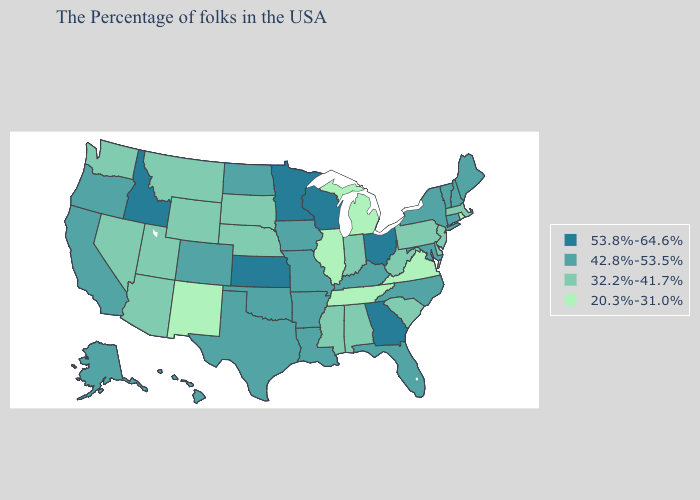How many symbols are there in the legend?
Short answer required. 4. What is the highest value in states that border Alabama?
Keep it brief. 53.8%-64.6%. Name the states that have a value in the range 20.3%-31.0%?
Give a very brief answer. Rhode Island, Virginia, Michigan, Tennessee, Illinois, New Mexico. Name the states that have a value in the range 32.2%-41.7%?
Concise answer only. Massachusetts, New Jersey, Delaware, Pennsylvania, South Carolina, West Virginia, Indiana, Alabama, Mississippi, Nebraska, South Dakota, Wyoming, Utah, Montana, Arizona, Nevada, Washington. What is the value of California?
Concise answer only. 42.8%-53.5%. Among the states that border Iowa , which have the highest value?
Be succinct. Wisconsin, Minnesota. Name the states that have a value in the range 20.3%-31.0%?
Be succinct. Rhode Island, Virginia, Michigan, Tennessee, Illinois, New Mexico. What is the highest value in the MidWest ?
Give a very brief answer. 53.8%-64.6%. What is the value of New Mexico?
Write a very short answer. 20.3%-31.0%. Name the states that have a value in the range 42.8%-53.5%?
Write a very short answer. Maine, New Hampshire, Vermont, Connecticut, New York, Maryland, North Carolina, Florida, Kentucky, Louisiana, Missouri, Arkansas, Iowa, Oklahoma, Texas, North Dakota, Colorado, California, Oregon, Alaska, Hawaii. Does the first symbol in the legend represent the smallest category?
Short answer required. No. Which states have the highest value in the USA?
Keep it brief. Ohio, Georgia, Wisconsin, Minnesota, Kansas, Idaho. What is the lowest value in the West?
Give a very brief answer. 20.3%-31.0%. What is the value of Pennsylvania?
Quick response, please. 32.2%-41.7%. What is the highest value in the Northeast ?
Concise answer only. 42.8%-53.5%. 